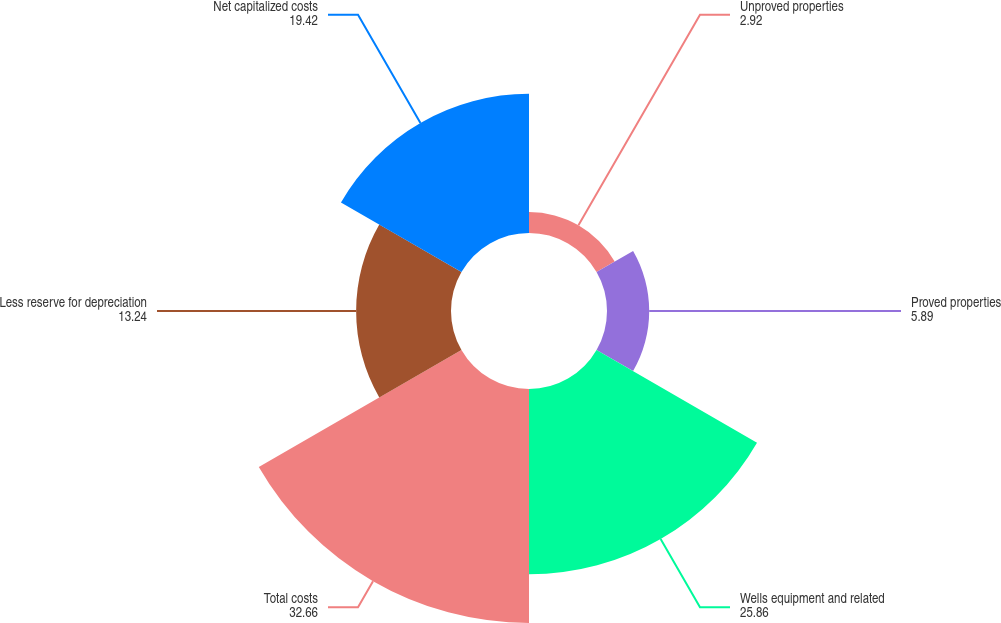<chart> <loc_0><loc_0><loc_500><loc_500><pie_chart><fcel>Unproved properties<fcel>Proved properties<fcel>Wells equipment and related<fcel>Total costs<fcel>Less reserve for depreciation<fcel>Net capitalized costs<nl><fcel>2.92%<fcel>5.89%<fcel>25.86%<fcel>32.66%<fcel>13.24%<fcel>19.42%<nl></chart> 